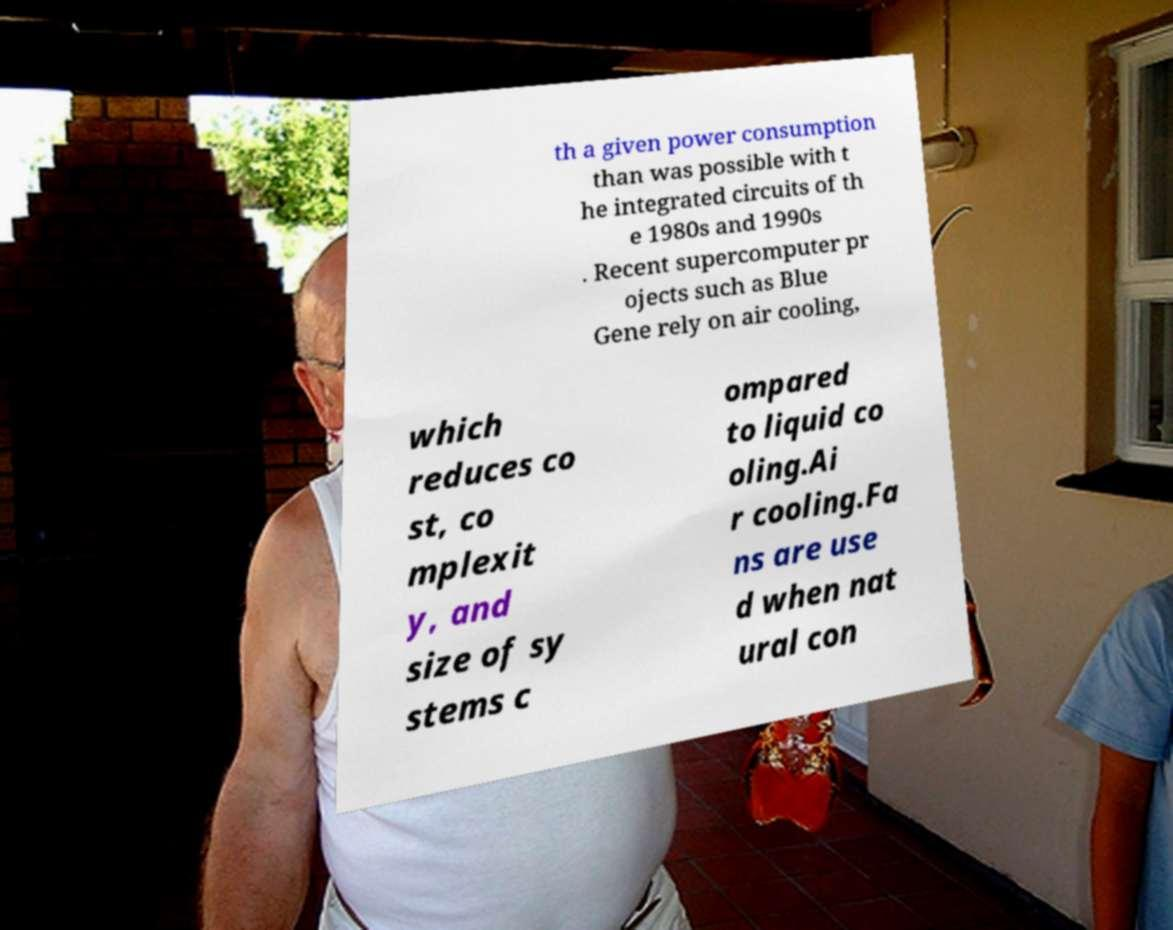For documentation purposes, I need the text within this image transcribed. Could you provide that? th a given power consumption than was possible with t he integrated circuits of th e 1980s and 1990s . Recent supercomputer pr ojects such as Blue Gene rely on air cooling, which reduces co st, co mplexit y, and size of sy stems c ompared to liquid co oling.Ai r cooling.Fa ns are use d when nat ural con 